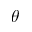Convert formula to latex. <formula><loc_0><loc_0><loc_500><loc_500>\theta</formula> 